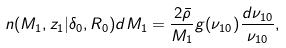Convert formula to latex. <formula><loc_0><loc_0><loc_500><loc_500>n ( M _ { 1 } , z _ { 1 } | \delta _ { 0 } , R _ { 0 } ) d M _ { 1 } = \frac { 2 \bar { \rho } } { M _ { 1 } } g ( \nu _ { 1 0 } ) \frac { d \nu _ { 1 0 } } { \nu _ { 1 0 } } ,</formula> 